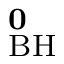Convert formula to latex. <formula><loc_0><loc_0><loc_500><loc_500>^ { 0 } _ { B H }</formula> 